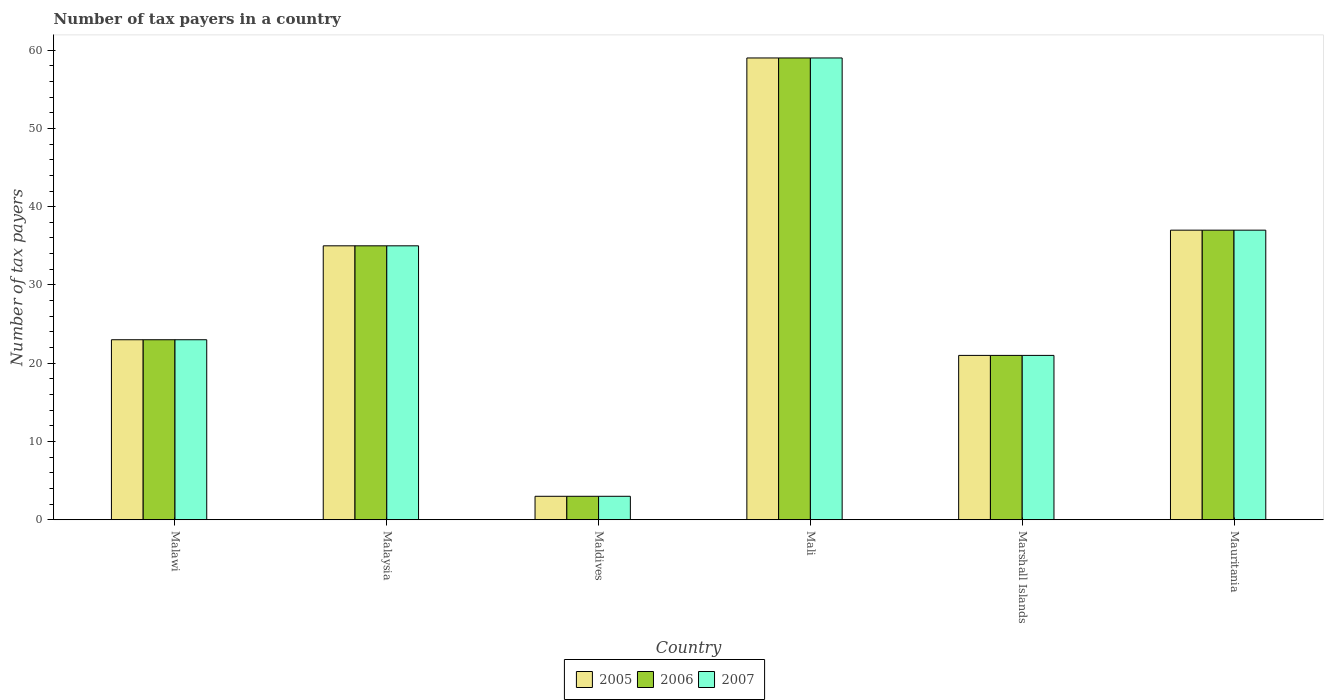How many groups of bars are there?
Keep it short and to the point. 6. Are the number of bars on each tick of the X-axis equal?
Your response must be concise. Yes. What is the label of the 6th group of bars from the left?
Your answer should be compact. Mauritania. What is the number of tax payers in in 2007 in Marshall Islands?
Offer a very short reply. 21. Across all countries, what is the minimum number of tax payers in in 2005?
Keep it short and to the point. 3. In which country was the number of tax payers in in 2006 maximum?
Give a very brief answer. Mali. In which country was the number of tax payers in in 2006 minimum?
Offer a very short reply. Maldives. What is the total number of tax payers in in 2005 in the graph?
Offer a very short reply. 178. What is the average number of tax payers in in 2006 per country?
Provide a succinct answer. 29.67. What is the difference between the number of tax payers in of/in 2007 and number of tax payers in of/in 2006 in Marshall Islands?
Your answer should be compact. 0. What is the ratio of the number of tax payers in in 2007 in Malaysia to that in Mauritania?
Keep it short and to the point. 0.95. Is the difference between the number of tax payers in in 2007 in Malaysia and Maldives greater than the difference between the number of tax payers in in 2006 in Malaysia and Maldives?
Offer a terse response. No. What is the difference between the highest and the lowest number of tax payers in in 2005?
Your response must be concise. 56. Is it the case that in every country, the sum of the number of tax payers in in 2005 and number of tax payers in in 2007 is greater than the number of tax payers in in 2006?
Offer a terse response. Yes. How many bars are there?
Provide a succinct answer. 18. How many countries are there in the graph?
Give a very brief answer. 6. What is the difference between two consecutive major ticks on the Y-axis?
Your answer should be compact. 10. Are the values on the major ticks of Y-axis written in scientific E-notation?
Offer a terse response. No. Does the graph contain any zero values?
Ensure brevity in your answer.  No. Does the graph contain grids?
Offer a terse response. No. Where does the legend appear in the graph?
Make the answer very short. Bottom center. How many legend labels are there?
Provide a succinct answer. 3. What is the title of the graph?
Provide a short and direct response. Number of tax payers in a country. What is the label or title of the Y-axis?
Provide a succinct answer. Number of tax payers. What is the Number of tax payers of 2005 in Malawi?
Ensure brevity in your answer.  23. What is the Number of tax payers of 2007 in Malawi?
Give a very brief answer. 23. What is the Number of tax payers in 2006 in Malaysia?
Provide a short and direct response. 35. What is the Number of tax payers in 2005 in Mali?
Your answer should be very brief. 59. What is the Number of tax payers of 2006 in Mali?
Ensure brevity in your answer.  59. What is the Number of tax payers in 2005 in Marshall Islands?
Make the answer very short. 21. What is the Number of tax payers of 2006 in Marshall Islands?
Offer a terse response. 21. Across all countries, what is the maximum Number of tax payers in 2007?
Provide a succinct answer. 59. Across all countries, what is the minimum Number of tax payers of 2005?
Offer a terse response. 3. What is the total Number of tax payers in 2005 in the graph?
Provide a short and direct response. 178. What is the total Number of tax payers in 2006 in the graph?
Make the answer very short. 178. What is the total Number of tax payers in 2007 in the graph?
Your response must be concise. 178. What is the difference between the Number of tax payers of 2007 in Malawi and that in Malaysia?
Offer a very short reply. -12. What is the difference between the Number of tax payers in 2005 in Malawi and that in Maldives?
Provide a short and direct response. 20. What is the difference between the Number of tax payers in 2006 in Malawi and that in Maldives?
Provide a short and direct response. 20. What is the difference between the Number of tax payers of 2005 in Malawi and that in Mali?
Provide a short and direct response. -36. What is the difference between the Number of tax payers in 2006 in Malawi and that in Mali?
Ensure brevity in your answer.  -36. What is the difference between the Number of tax payers of 2007 in Malawi and that in Mali?
Ensure brevity in your answer.  -36. What is the difference between the Number of tax payers of 2005 in Malawi and that in Marshall Islands?
Give a very brief answer. 2. What is the difference between the Number of tax payers in 2006 in Malawi and that in Marshall Islands?
Provide a succinct answer. 2. What is the difference between the Number of tax payers in 2007 in Malawi and that in Marshall Islands?
Ensure brevity in your answer.  2. What is the difference between the Number of tax payers in 2007 in Malaysia and that in Maldives?
Provide a succinct answer. 32. What is the difference between the Number of tax payers of 2006 in Malaysia and that in Mali?
Make the answer very short. -24. What is the difference between the Number of tax payers of 2007 in Malaysia and that in Mali?
Offer a terse response. -24. What is the difference between the Number of tax payers of 2006 in Malaysia and that in Marshall Islands?
Your response must be concise. 14. What is the difference between the Number of tax payers of 2006 in Malaysia and that in Mauritania?
Give a very brief answer. -2. What is the difference between the Number of tax payers of 2007 in Malaysia and that in Mauritania?
Keep it short and to the point. -2. What is the difference between the Number of tax payers in 2005 in Maldives and that in Mali?
Keep it short and to the point. -56. What is the difference between the Number of tax payers in 2006 in Maldives and that in Mali?
Provide a succinct answer. -56. What is the difference between the Number of tax payers of 2007 in Maldives and that in Mali?
Give a very brief answer. -56. What is the difference between the Number of tax payers in 2005 in Maldives and that in Marshall Islands?
Ensure brevity in your answer.  -18. What is the difference between the Number of tax payers in 2007 in Maldives and that in Marshall Islands?
Give a very brief answer. -18. What is the difference between the Number of tax payers of 2005 in Maldives and that in Mauritania?
Offer a terse response. -34. What is the difference between the Number of tax payers in 2006 in Maldives and that in Mauritania?
Your answer should be compact. -34. What is the difference between the Number of tax payers in 2007 in Maldives and that in Mauritania?
Your response must be concise. -34. What is the difference between the Number of tax payers of 2006 in Mali and that in Marshall Islands?
Provide a succinct answer. 38. What is the difference between the Number of tax payers of 2006 in Mali and that in Mauritania?
Provide a short and direct response. 22. What is the difference between the Number of tax payers of 2005 in Marshall Islands and that in Mauritania?
Offer a terse response. -16. What is the difference between the Number of tax payers in 2005 in Malawi and the Number of tax payers in 2006 in Malaysia?
Give a very brief answer. -12. What is the difference between the Number of tax payers in 2005 in Malawi and the Number of tax payers in 2007 in Maldives?
Your answer should be compact. 20. What is the difference between the Number of tax payers in 2005 in Malawi and the Number of tax payers in 2006 in Mali?
Your answer should be very brief. -36. What is the difference between the Number of tax payers in 2005 in Malawi and the Number of tax payers in 2007 in Mali?
Offer a terse response. -36. What is the difference between the Number of tax payers in 2006 in Malawi and the Number of tax payers in 2007 in Mali?
Provide a succinct answer. -36. What is the difference between the Number of tax payers of 2006 in Malawi and the Number of tax payers of 2007 in Marshall Islands?
Make the answer very short. 2. What is the difference between the Number of tax payers of 2005 in Malawi and the Number of tax payers of 2006 in Mauritania?
Provide a succinct answer. -14. What is the difference between the Number of tax payers in 2005 in Malawi and the Number of tax payers in 2007 in Mauritania?
Offer a very short reply. -14. What is the difference between the Number of tax payers of 2005 in Malaysia and the Number of tax payers of 2006 in Maldives?
Make the answer very short. 32. What is the difference between the Number of tax payers of 2005 in Malaysia and the Number of tax payers of 2006 in Mali?
Your response must be concise. -24. What is the difference between the Number of tax payers in 2005 in Malaysia and the Number of tax payers in 2007 in Mali?
Make the answer very short. -24. What is the difference between the Number of tax payers in 2006 in Malaysia and the Number of tax payers in 2007 in Mali?
Ensure brevity in your answer.  -24. What is the difference between the Number of tax payers of 2005 in Malaysia and the Number of tax payers of 2006 in Marshall Islands?
Your answer should be compact. 14. What is the difference between the Number of tax payers in 2006 in Malaysia and the Number of tax payers in 2007 in Marshall Islands?
Provide a short and direct response. 14. What is the difference between the Number of tax payers in 2005 in Malaysia and the Number of tax payers in 2006 in Mauritania?
Provide a succinct answer. -2. What is the difference between the Number of tax payers in 2005 in Malaysia and the Number of tax payers in 2007 in Mauritania?
Keep it short and to the point. -2. What is the difference between the Number of tax payers of 2006 in Malaysia and the Number of tax payers of 2007 in Mauritania?
Ensure brevity in your answer.  -2. What is the difference between the Number of tax payers of 2005 in Maldives and the Number of tax payers of 2006 in Mali?
Your response must be concise. -56. What is the difference between the Number of tax payers in 2005 in Maldives and the Number of tax payers in 2007 in Mali?
Your answer should be very brief. -56. What is the difference between the Number of tax payers of 2006 in Maldives and the Number of tax payers of 2007 in Mali?
Provide a succinct answer. -56. What is the difference between the Number of tax payers in 2005 in Maldives and the Number of tax payers in 2006 in Marshall Islands?
Give a very brief answer. -18. What is the difference between the Number of tax payers in 2005 in Maldives and the Number of tax payers in 2007 in Marshall Islands?
Your response must be concise. -18. What is the difference between the Number of tax payers in 2006 in Maldives and the Number of tax payers in 2007 in Marshall Islands?
Keep it short and to the point. -18. What is the difference between the Number of tax payers in 2005 in Maldives and the Number of tax payers in 2006 in Mauritania?
Your answer should be very brief. -34. What is the difference between the Number of tax payers in 2005 in Maldives and the Number of tax payers in 2007 in Mauritania?
Provide a short and direct response. -34. What is the difference between the Number of tax payers in 2006 in Maldives and the Number of tax payers in 2007 in Mauritania?
Ensure brevity in your answer.  -34. What is the difference between the Number of tax payers in 2006 in Marshall Islands and the Number of tax payers in 2007 in Mauritania?
Make the answer very short. -16. What is the average Number of tax payers of 2005 per country?
Offer a very short reply. 29.67. What is the average Number of tax payers in 2006 per country?
Offer a terse response. 29.67. What is the average Number of tax payers in 2007 per country?
Offer a very short reply. 29.67. What is the difference between the Number of tax payers in 2005 and Number of tax payers in 2006 in Malaysia?
Keep it short and to the point. 0. What is the difference between the Number of tax payers in 2005 and Number of tax payers in 2007 in Malaysia?
Your response must be concise. 0. What is the difference between the Number of tax payers of 2005 and Number of tax payers of 2006 in Maldives?
Offer a very short reply. 0. What is the difference between the Number of tax payers of 2005 and Number of tax payers of 2007 in Maldives?
Your response must be concise. 0. What is the difference between the Number of tax payers of 2005 and Number of tax payers of 2007 in Mali?
Provide a short and direct response. 0. What is the difference between the Number of tax payers in 2006 and Number of tax payers in 2007 in Mali?
Your response must be concise. 0. What is the difference between the Number of tax payers of 2005 and Number of tax payers of 2007 in Mauritania?
Your answer should be very brief. 0. What is the ratio of the Number of tax payers of 2005 in Malawi to that in Malaysia?
Provide a succinct answer. 0.66. What is the ratio of the Number of tax payers of 2006 in Malawi to that in Malaysia?
Keep it short and to the point. 0.66. What is the ratio of the Number of tax payers of 2007 in Malawi to that in Malaysia?
Provide a succinct answer. 0.66. What is the ratio of the Number of tax payers of 2005 in Malawi to that in Maldives?
Give a very brief answer. 7.67. What is the ratio of the Number of tax payers of 2006 in Malawi to that in Maldives?
Keep it short and to the point. 7.67. What is the ratio of the Number of tax payers in 2007 in Malawi to that in Maldives?
Give a very brief answer. 7.67. What is the ratio of the Number of tax payers in 2005 in Malawi to that in Mali?
Provide a succinct answer. 0.39. What is the ratio of the Number of tax payers in 2006 in Malawi to that in Mali?
Your response must be concise. 0.39. What is the ratio of the Number of tax payers of 2007 in Malawi to that in Mali?
Make the answer very short. 0.39. What is the ratio of the Number of tax payers of 2005 in Malawi to that in Marshall Islands?
Provide a short and direct response. 1.1. What is the ratio of the Number of tax payers of 2006 in Malawi to that in Marshall Islands?
Give a very brief answer. 1.1. What is the ratio of the Number of tax payers of 2007 in Malawi to that in Marshall Islands?
Keep it short and to the point. 1.1. What is the ratio of the Number of tax payers of 2005 in Malawi to that in Mauritania?
Provide a succinct answer. 0.62. What is the ratio of the Number of tax payers in 2006 in Malawi to that in Mauritania?
Ensure brevity in your answer.  0.62. What is the ratio of the Number of tax payers in 2007 in Malawi to that in Mauritania?
Your response must be concise. 0.62. What is the ratio of the Number of tax payers in 2005 in Malaysia to that in Maldives?
Make the answer very short. 11.67. What is the ratio of the Number of tax payers of 2006 in Malaysia to that in Maldives?
Keep it short and to the point. 11.67. What is the ratio of the Number of tax payers of 2007 in Malaysia to that in Maldives?
Make the answer very short. 11.67. What is the ratio of the Number of tax payers of 2005 in Malaysia to that in Mali?
Provide a succinct answer. 0.59. What is the ratio of the Number of tax payers of 2006 in Malaysia to that in Mali?
Ensure brevity in your answer.  0.59. What is the ratio of the Number of tax payers of 2007 in Malaysia to that in Mali?
Provide a short and direct response. 0.59. What is the ratio of the Number of tax payers of 2007 in Malaysia to that in Marshall Islands?
Your response must be concise. 1.67. What is the ratio of the Number of tax payers of 2005 in Malaysia to that in Mauritania?
Make the answer very short. 0.95. What is the ratio of the Number of tax payers in 2006 in Malaysia to that in Mauritania?
Offer a very short reply. 0.95. What is the ratio of the Number of tax payers of 2007 in Malaysia to that in Mauritania?
Your answer should be very brief. 0.95. What is the ratio of the Number of tax payers in 2005 in Maldives to that in Mali?
Give a very brief answer. 0.05. What is the ratio of the Number of tax payers in 2006 in Maldives to that in Mali?
Keep it short and to the point. 0.05. What is the ratio of the Number of tax payers in 2007 in Maldives to that in Mali?
Provide a short and direct response. 0.05. What is the ratio of the Number of tax payers of 2005 in Maldives to that in Marshall Islands?
Provide a succinct answer. 0.14. What is the ratio of the Number of tax payers in 2006 in Maldives to that in Marshall Islands?
Provide a short and direct response. 0.14. What is the ratio of the Number of tax payers in 2007 in Maldives to that in Marshall Islands?
Give a very brief answer. 0.14. What is the ratio of the Number of tax payers in 2005 in Maldives to that in Mauritania?
Provide a short and direct response. 0.08. What is the ratio of the Number of tax payers in 2006 in Maldives to that in Mauritania?
Offer a terse response. 0.08. What is the ratio of the Number of tax payers of 2007 in Maldives to that in Mauritania?
Your answer should be very brief. 0.08. What is the ratio of the Number of tax payers of 2005 in Mali to that in Marshall Islands?
Your response must be concise. 2.81. What is the ratio of the Number of tax payers in 2006 in Mali to that in Marshall Islands?
Keep it short and to the point. 2.81. What is the ratio of the Number of tax payers of 2007 in Mali to that in Marshall Islands?
Provide a short and direct response. 2.81. What is the ratio of the Number of tax payers in 2005 in Mali to that in Mauritania?
Your answer should be very brief. 1.59. What is the ratio of the Number of tax payers of 2006 in Mali to that in Mauritania?
Your answer should be compact. 1.59. What is the ratio of the Number of tax payers in 2007 in Mali to that in Mauritania?
Provide a succinct answer. 1.59. What is the ratio of the Number of tax payers of 2005 in Marshall Islands to that in Mauritania?
Provide a succinct answer. 0.57. What is the ratio of the Number of tax payers of 2006 in Marshall Islands to that in Mauritania?
Ensure brevity in your answer.  0.57. What is the ratio of the Number of tax payers of 2007 in Marshall Islands to that in Mauritania?
Your answer should be very brief. 0.57. What is the difference between the highest and the second highest Number of tax payers of 2005?
Provide a succinct answer. 22. What is the difference between the highest and the second highest Number of tax payers in 2006?
Offer a very short reply. 22. What is the difference between the highest and the second highest Number of tax payers of 2007?
Ensure brevity in your answer.  22. What is the difference between the highest and the lowest Number of tax payers in 2005?
Offer a terse response. 56. What is the difference between the highest and the lowest Number of tax payers of 2006?
Keep it short and to the point. 56. What is the difference between the highest and the lowest Number of tax payers in 2007?
Ensure brevity in your answer.  56. 